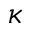Convert formula to latex. <formula><loc_0><loc_0><loc_500><loc_500>\kappa</formula> 